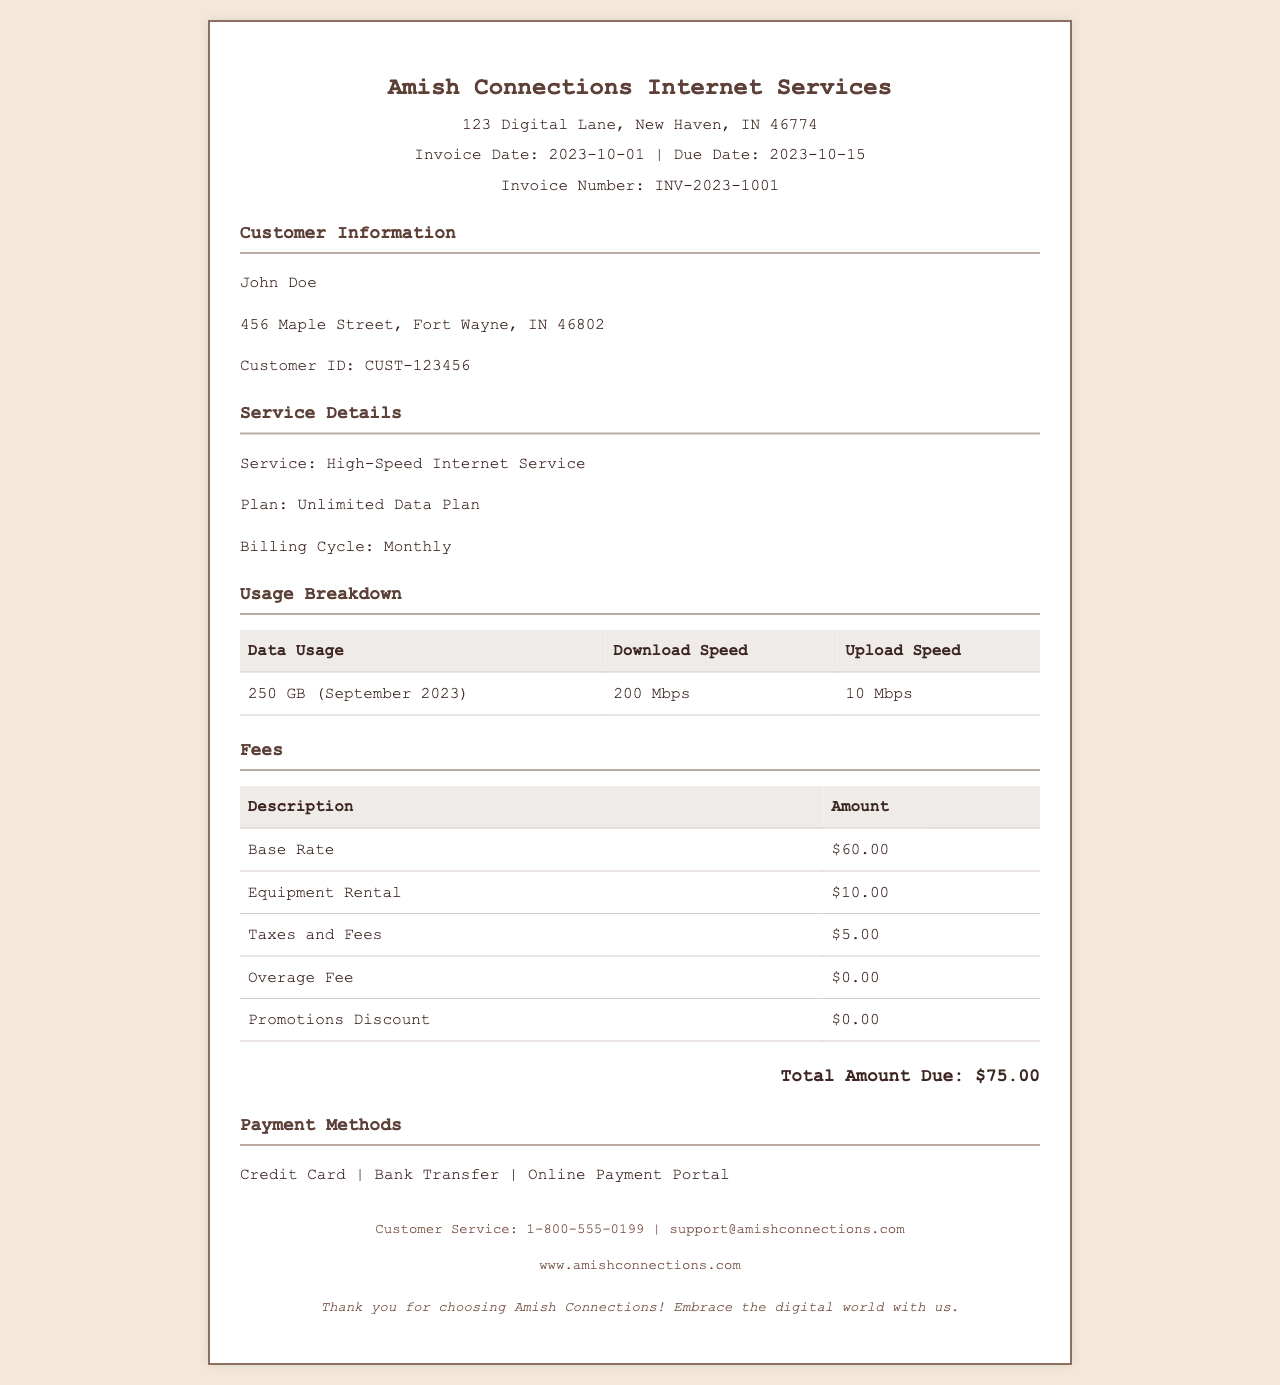What is the invoice number? The invoice number is clearly stated at the top of the document under the Invoice Date section.
Answer: INV-2023-1001 What is the customer name? The customer name is mentioned in the Customer Information section of the document.
Answer: John Doe What is the billing cycle? The billing cycle is specified under the Service Details section of the invoice.
Answer: Monthly What is the total amount due? The total amount due is shown prominently in the total amount section of the document.
Answer: $75.00 What is the date of the invoice? The date of the invoice is indicated at the top along with the due date.
Answer: 2023-10-01 What is the download speed? The download speed is part of the Usage Breakdown table, providing details about the service.
Answer: 200 Mbps How much is the base rate? The base rate is listed in the Fees section of the invoice.
Answer: $60.00 Is there an overage fee? This is found under the Fees section, indicating any additional charges beyond the plan.
Answer: $0.00 What type of internet service is provided? The type of internet service is stated in the Service Details section of the document.
Answer: High-Speed Internet Service 